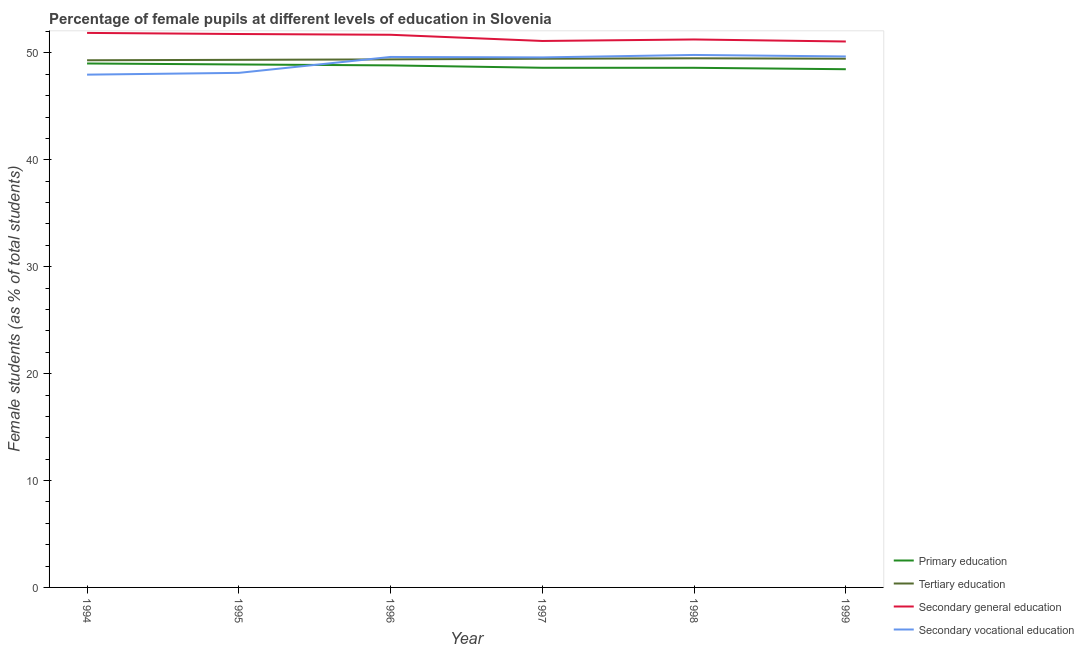How many different coloured lines are there?
Offer a very short reply. 4. What is the percentage of female students in tertiary education in 1996?
Offer a very short reply. 49.39. Across all years, what is the maximum percentage of female students in secondary education?
Provide a short and direct response. 51.87. Across all years, what is the minimum percentage of female students in secondary education?
Ensure brevity in your answer.  51.07. In which year was the percentage of female students in secondary vocational education minimum?
Your answer should be compact. 1994. What is the total percentage of female students in primary education in the graph?
Offer a very short reply. 292.46. What is the difference between the percentage of female students in tertiary education in 1995 and that in 1996?
Provide a short and direct response. -0.04. What is the difference between the percentage of female students in secondary vocational education in 1996 and the percentage of female students in secondary education in 1994?
Your response must be concise. -2.25. What is the average percentage of female students in primary education per year?
Make the answer very short. 48.74. In the year 1995, what is the difference between the percentage of female students in secondary education and percentage of female students in primary education?
Your response must be concise. 2.85. What is the ratio of the percentage of female students in secondary education in 1996 to that in 1998?
Make the answer very short. 1.01. Is the percentage of female students in tertiary education in 1994 less than that in 1996?
Your answer should be very brief. Yes. Is the difference between the percentage of female students in tertiary education in 1996 and 1997 greater than the difference between the percentage of female students in secondary education in 1996 and 1997?
Give a very brief answer. No. What is the difference between the highest and the second highest percentage of female students in secondary education?
Your answer should be compact. 0.1. What is the difference between the highest and the lowest percentage of female students in secondary vocational education?
Your answer should be compact. 1.84. Does the percentage of female students in primary education monotonically increase over the years?
Provide a short and direct response. No. Is the percentage of female students in secondary education strictly greater than the percentage of female students in secondary vocational education over the years?
Give a very brief answer. Yes. How many lines are there?
Keep it short and to the point. 4. How many years are there in the graph?
Offer a terse response. 6. Does the graph contain grids?
Offer a terse response. No. How are the legend labels stacked?
Your answer should be compact. Vertical. What is the title of the graph?
Offer a terse response. Percentage of female pupils at different levels of education in Slovenia. What is the label or title of the Y-axis?
Make the answer very short. Female students (as % of total students). What is the Female students (as % of total students) in Primary education in 1994?
Give a very brief answer. 49.01. What is the Female students (as % of total students) of Tertiary education in 1994?
Give a very brief answer. 49.31. What is the Female students (as % of total students) in Secondary general education in 1994?
Your response must be concise. 51.87. What is the Female students (as % of total students) of Secondary vocational education in 1994?
Keep it short and to the point. 47.97. What is the Female students (as % of total students) in Primary education in 1995?
Provide a short and direct response. 48.92. What is the Female students (as % of total students) of Tertiary education in 1995?
Provide a short and direct response. 49.35. What is the Female students (as % of total students) of Secondary general education in 1995?
Offer a terse response. 51.77. What is the Female students (as % of total students) of Secondary vocational education in 1995?
Make the answer very short. 48.13. What is the Female students (as % of total students) in Primary education in 1996?
Make the answer very short. 48.83. What is the Female students (as % of total students) in Tertiary education in 1996?
Provide a short and direct response. 49.39. What is the Female students (as % of total students) of Secondary general education in 1996?
Your answer should be compact. 51.7. What is the Female students (as % of total students) of Secondary vocational education in 1996?
Offer a very short reply. 49.62. What is the Female students (as % of total students) of Primary education in 1997?
Give a very brief answer. 48.61. What is the Female students (as % of total students) of Tertiary education in 1997?
Make the answer very short. 49.46. What is the Female students (as % of total students) of Secondary general education in 1997?
Keep it short and to the point. 51.12. What is the Female students (as % of total students) of Secondary vocational education in 1997?
Offer a terse response. 49.58. What is the Female students (as % of total students) in Primary education in 1998?
Provide a short and direct response. 48.61. What is the Female students (as % of total students) of Tertiary education in 1998?
Your response must be concise. 49.5. What is the Female students (as % of total students) of Secondary general education in 1998?
Ensure brevity in your answer.  51.26. What is the Female students (as % of total students) in Secondary vocational education in 1998?
Give a very brief answer. 49.81. What is the Female students (as % of total students) in Primary education in 1999?
Offer a very short reply. 48.47. What is the Female students (as % of total students) of Tertiary education in 1999?
Provide a succinct answer. 49.46. What is the Female students (as % of total students) of Secondary general education in 1999?
Your response must be concise. 51.07. What is the Female students (as % of total students) of Secondary vocational education in 1999?
Offer a terse response. 49.67. Across all years, what is the maximum Female students (as % of total students) in Primary education?
Give a very brief answer. 49.01. Across all years, what is the maximum Female students (as % of total students) in Tertiary education?
Your answer should be very brief. 49.5. Across all years, what is the maximum Female students (as % of total students) of Secondary general education?
Keep it short and to the point. 51.87. Across all years, what is the maximum Female students (as % of total students) of Secondary vocational education?
Your answer should be compact. 49.81. Across all years, what is the minimum Female students (as % of total students) of Primary education?
Make the answer very short. 48.47. Across all years, what is the minimum Female students (as % of total students) of Tertiary education?
Provide a short and direct response. 49.31. Across all years, what is the minimum Female students (as % of total students) of Secondary general education?
Make the answer very short. 51.07. Across all years, what is the minimum Female students (as % of total students) of Secondary vocational education?
Your answer should be very brief. 47.97. What is the total Female students (as % of total students) of Primary education in the graph?
Keep it short and to the point. 292.46. What is the total Female students (as % of total students) of Tertiary education in the graph?
Provide a short and direct response. 296.47. What is the total Female students (as % of total students) in Secondary general education in the graph?
Offer a very short reply. 308.78. What is the total Female students (as % of total students) of Secondary vocational education in the graph?
Your answer should be very brief. 294.78. What is the difference between the Female students (as % of total students) in Primary education in 1994 and that in 1995?
Your answer should be compact. 0.09. What is the difference between the Female students (as % of total students) in Tertiary education in 1994 and that in 1995?
Give a very brief answer. -0.04. What is the difference between the Female students (as % of total students) in Secondary general education in 1994 and that in 1995?
Your answer should be very brief. 0.1. What is the difference between the Female students (as % of total students) in Secondary vocational education in 1994 and that in 1995?
Offer a very short reply. -0.17. What is the difference between the Female students (as % of total students) in Primary education in 1994 and that in 1996?
Your answer should be compact. 0.18. What is the difference between the Female students (as % of total students) of Tertiary education in 1994 and that in 1996?
Keep it short and to the point. -0.08. What is the difference between the Female students (as % of total students) of Secondary general education in 1994 and that in 1996?
Your answer should be very brief. 0.17. What is the difference between the Female students (as % of total students) in Secondary vocational education in 1994 and that in 1996?
Give a very brief answer. -1.65. What is the difference between the Female students (as % of total students) in Primary education in 1994 and that in 1997?
Provide a succinct answer. 0.4. What is the difference between the Female students (as % of total students) in Tertiary education in 1994 and that in 1997?
Ensure brevity in your answer.  -0.14. What is the difference between the Female students (as % of total students) in Secondary general education in 1994 and that in 1997?
Your answer should be very brief. 0.75. What is the difference between the Female students (as % of total students) of Secondary vocational education in 1994 and that in 1997?
Provide a short and direct response. -1.61. What is the difference between the Female students (as % of total students) of Primary education in 1994 and that in 1998?
Offer a very short reply. 0.4. What is the difference between the Female students (as % of total students) of Tertiary education in 1994 and that in 1998?
Offer a very short reply. -0.18. What is the difference between the Female students (as % of total students) in Secondary general education in 1994 and that in 1998?
Your response must be concise. 0.61. What is the difference between the Female students (as % of total students) of Secondary vocational education in 1994 and that in 1998?
Make the answer very short. -1.84. What is the difference between the Female students (as % of total students) of Primary education in 1994 and that in 1999?
Provide a succinct answer. 0.54. What is the difference between the Female students (as % of total students) of Tertiary education in 1994 and that in 1999?
Your response must be concise. -0.15. What is the difference between the Female students (as % of total students) of Secondary general education in 1994 and that in 1999?
Your response must be concise. 0.8. What is the difference between the Female students (as % of total students) in Secondary vocational education in 1994 and that in 1999?
Keep it short and to the point. -1.7. What is the difference between the Female students (as % of total students) in Primary education in 1995 and that in 1996?
Your answer should be very brief. 0.09. What is the difference between the Female students (as % of total students) of Tertiary education in 1995 and that in 1996?
Your answer should be very brief. -0.04. What is the difference between the Female students (as % of total students) in Secondary general education in 1995 and that in 1996?
Provide a short and direct response. 0.07. What is the difference between the Female students (as % of total students) of Secondary vocational education in 1995 and that in 1996?
Give a very brief answer. -1.49. What is the difference between the Female students (as % of total students) of Primary education in 1995 and that in 1997?
Your answer should be very brief. 0.31. What is the difference between the Female students (as % of total students) in Tertiary education in 1995 and that in 1997?
Your response must be concise. -0.1. What is the difference between the Female students (as % of total students) of Secondary general education in 1995 and that in 1997?
Your answer should be compact. 0.65. What is the difference between the Female students (as % of total students) of Secondary vocational education in 1995 and that in 1997?
Provide a succinct answer. -1.45. What is the difference between the Female students (as % of total students) in Primary education in 1995 and that in 1998?
Your response must be concise. 0.31. What is the difference between the Female students (as % of total students) of Tertiary education in 1995 and that in 1998?
Provide a succinct answer. -0.14. What is the difference between the Female students (as % of total students) in Secondary general education in 1995 and that in 1998?
Your answer should be very brief. 0.51. What is the difference between the Female students (as % of total students) of Secondary vocational education in 1995 and that in 1998?
Your response must be concise. -1.68. What is the difference between the Female students (as % of total students) of Primary education in 1995 and that in 1999?
Your response must be concise. 0.44. What is the difference between the Female students (as % of total students) of Tertiary education in 1995 and that in 1999?
Your answer should be compact. -0.11. What is the difference between the Female students (as % of total students) in Secondary general education in 1995 and that in 1999?
Ensure brevity in your answer.  0.7. What is the difference between the Female students (as % of total students) in Secondary vocational education in 1995 and that in 1999?
Provide a short and direct response. -1.53. What is the difference between the Female students (as % of total students) in Primary education in 1996 and that in 1997?
Give a very brief answer. 0.22. What is the difference between the Female students (as % of total students) of Tertiary education in 1996 and that in 1997?
Ensure brevity in your answer.  -0.06. What is the difference between the Female students (as % of total students) of Secondary general education in 1996 and that in 1997?
Ensure brevity in your answer.  0.58. What is the difference between the Female students (as % of total students) of Secondary vocational education in 1996 and that in 1997?
Provide a short and direct response. 0.04. What is the difference between the Female students (as % of total students) in Primary education in 1996 and that in 1998?
Your answer should be very brief. 0.22. What is the difference between the Female students (as % of total students) in Tertiary education in 1996 and that in 1998?
Your answer should be compact. -0.1. What is the difference between the Female students (as % of total students) in Secondary general education in 1996 and that in 1998?
Ensure brevity in your answer.  0.44. What is the difference between the Female students (as % of total students) of Secondary vocational education in 1996 and that in 1998?
Keep it short and to the point. -0.19. What is the difference between the Female students (as % of total students) in Primary education in 1996 and that in 1999?
Keep it short and to the point. 0.36. What is the difference between the Female students (as % of total students) in Tertiary education in 1996 and that in 1999?
Offer a very short reply. -0.06. What is the difference between the Female students (as % of total students) in Secondary general education in 1996 and that in 1999?
Provide a short and direct response. 0.63. What is the difference between the Female students (as % of total students) in Secondary vocational education in 1996 and that in 1999?
Ensure brevity in your answer.  -0.05. What is the difference between the Female students (as % of total students) in Primary education in 1997 and that in 1998?
Provide a succinct answer. 0. What is the difference between the Female students (as % of total students) in Tertiary education in 1997 and that in 1998?
Offer a terse response. -0.04. What is the difference between the Female students (as % of total students) of Secondary general education in 1997 and that in 1998?
Your response must be concise. -0.14. What is the difference between the Female students (as % of total students) of Secondary vocational education in 1997 and that in 1998?
Ensure brevity in your answer.  -0.23. What is the difference between the Female students (as % of total students) in Primary education in 1997 and that in 1999?
Your answer should be compact. 0.14. What is the difference between the Female students (as % of total students) of Tertiary education in 1997 and that in 1999?
Ensure brevity in your answer.  -0. What is the difference between the Female students (as % of total students) in Secondary vocational education in 1997 and that in 1999?
Your answer should be very brief. -0.09. What is the difference between the Female students (as % of total students) in Primary education in 1998 and that in 1999?
Your answer should be compact. 0.13. What is the difference between the Female students (as % of total students) of Tertiary education in 1998 and that in 1999?
Offer a very short reply. 0.04. What is the difference between the Female students (as % of total students) in Secondary general education in 1998 and that in 1999?
Offer a very short reply. 0.19. What is the difference between the Female students (as % of total students) in Secondary vocational education in 1998 and that in 1999?
Provide a short and direct response. 0.14. What is the difference between the Female students (as % of total students) of Primary education in 1994 and the Female students (as % of total students) of Tertiary education in 1995?
Ensure brevity in your answer.  -0.34. What is the difference between the Female students (as % of total students) in Primary education in 1994 and the Female students (as % of total students) in Secondary general education in 1995?
Offer a terse response. -2.76. What is the difference between the Female students (as % of total students) of Primary education in 1994 and the Female students (as % of total students) of Secondary vocational education in 1995?
Offer a terse response. 0.88. What is the difference between the Female students (as % of total students) in Tertiary education in 1994 and the Female students (as % of total students) in Secondary general education in 1995?
Your answer should be compact. -2.46. What is the difference between the Female students (as % of total students) of Tertiary education in 1994 and the Female students (as % of total students) of Secondary vocational education in 1995?
Offer a very short reply. 1.18. What is the difference between the Female students (as % of total students) in Secondary general education in 1994 and the Female students (as % of total students) in Secondary vocational education in 1995?
Offer a very short reply. 3.74. What is the difference between the Female students (as % of total students) of Primary education in 1994 and the Female students (as % of total students) of Tertiary education in 1996?
Your answer should be compact. -0.38. What is the difference between the Female students (as % of total students) in Primary education in 1994 and the Female students (as % of total students) in Secondary general education in 1996?
Your answer should be very brief. -2.69. What is the difference between the Female students (as % of total students) in Primary education in 1994 and the Female students (as % of total students) in Secondary vocational education in 1996?
Give a very brief answer. -0.61. What is the difference between the Female students (as % of total students) in Tertiary education in 1994 and the Female students (as % of total students) in Secondary general education in 1996?
Ensure brevity in your answer.  -2.39. What is the difference between the Female students (as % of total students) of Tertiary education in 1994 and the Female students (as % of total students) of Secondary vocational education in 1996?
Make the answer very short. -0.31. What is the difference between the Female students (as % of total students) in Secondary general education in 1994 and the Female students (as % of total students) in Secondary vocational education in 1996?
Give a very brief answer. 2.25. What is the difference between the Female students (as % of total students) in Primary education in 1994 and the Female students (as % of total students) in Tertiary education in 1997?
Provide a succinct answer. -0.45. What is the difference between the Female students (as % of total students) of Primary education in 1994 and the Female students (as % of total students) of Secondary general education in 1997?
Keep it short and to the point. -2.11. What is the difference between the Female students (as % of total students) of Primary education in 1994 and the Female students (as % of total students) of Secondary vocational education in 1997?
Ensure brevity in your answer.  -0.57. What is the difference between the Female students (as % of total students) of Tertiary education in 1994 and the Female students (as % of total students) of Secondary general education in 1997?
Make the answer very short. -1.8. What is the difference between the Female students (as % of total students) of Tertiary education in 1994 and the Female students (as % of total students) of Secondary vocational education in 1997?
Make the answer very short. -0.27. What is the difference between the Female students (as % of total students) in Secondary general education in 1994 and the Female students (as % of total students) in Secondary vocational education in 1997?
Your response must be concise. 2.29. What is the difference between the Female students (as % of total students) in Primary education in 1994 and the Female students (as % of total students) in Tertiary education in 1998?
Your answer should be very brief. -0.48. What is the difference between the Female students (as % of total students) in Primary education in 1994 and the Female students (as % of total students) in Secondary general education in 1998?
Offer a very short reply. -2.25. What is the difference between the Female students (as % of total students) in Primary education in 1994 and the Female students (as % of total students) in Secondary vocational education in 1998?
Provide a succinct answer. -0.8. What is the difference between the Female students (as % of total students) of Tertiary education in 1994 and the Female students (as % of total students) of Secondary general education in 1998?
Ensure brevity in your answer.  -1.95. What is the difference between the Female students (as % of total students) of Tertiary education in 1994 and the Female students (as % of total students) of Secondary vocational education in 1998?
Your answer should be very brief. -0.5. What is the difference between the Female students (as % of total students) in Secondary general education in 1994 and the Female students (as % of total students) in Secondary vocational education in 1998?
Provide a short and direct response. 2.06. What is the difference between the Female students (as % of total students) of Primary education in 1994 and the Female students (as % of total students) of Tertiary education in 1999?
Your response must be concise. -0.45. What is the difference between the Female students (as % of total students) of Primary education in 1994 and the Female students (as % of total students) of Secondary general education in 1999?
Ensure brevity in your answer.  -2.06. What is the difference between the Female students (as % of total students) in Primary education in 1994 and the Female students (as % of total students) in Secondary vocational education in 1999?
Give a very brief answer. -0.66. What is the difference between the Female students (as % of total students) in Tertiary education in 1994 and the Female students (as % of total students) in Secondary general education in 1999?
Ensure brevity in your answer.  -1.75. What is the difference between the Female students (as % of total students) in Tertiary education in 1994 and the Female students (as % of total students) in Secondary vocational education in 1999?
Ensure brevity in your answer.  -0.36. What is the difference between the Female students (as % of total students) of Secondary general education in 1994 and the Female students (as % of total students) of Secondary vocational education in 1999?
Your answer should be very brief. 2.2. What is the difference between the Female students (as % of total students) in Primary education in 1995 and the Female students (as % of total students) in Tertiary education in 1996?
Your response must be concise. -0.48. What is the difference between the Female students (as % of total students) in Primary education in 1995 and the Female students (as % of total students) in Secondary general education in 1996?
Make the answer very short. -2.78. What is the difference between the Female students (as % of total students) in Primary education in 1995 and the Female students (as % of total students) in Secondary vocational education in 1996?
Ensure brevity in your answer.  -0.7. What is the difference between the Female students (as % of total students) of Tertiary education in 1995 and the Female students (as % of total students) of Secondary general education in 1996?
Ensure brevity in your answer.  -2.35. What is the difference between the Female students (as % of total students) of Tertiary education in 1995 and the Female students (as % of total students) of Secondary vocational education in 1996?
Keep it short and to the point. -0.27. What is the difference between the Female students (as % of total students) of Secondary general education in 1995 and the Female students (as % of total students) of Secondary vocational education in 1996?
Your answer should be very brief. 2.15. What is the difference between the Female students (as % of total students) of Primary education in 1995 and the Female students (as % of total students) of Tertiary education in 1997?
Make the answer very short. -0.54. What is the difference between the Female students (as % of total students) in Primary education in 1995 and the Female students (as % of total students) in Secondary general education in 1997?
Offer a very short reply. -2.2. What is the difference between the Female students (as % of total students) of Primary education in 1995 and the Female students (as % of total students) of Secondary vocational education in 1997?
Provide a succinct answer. -0.66. What is the difference between the Female students (as % of total students) of Tertiary education in 1995 and the Female students (as % of total students) of Secondary general education in 1997?
Your answer should be compact. -1.76. What is the difference between the Female students (as % of total students) of Tertiary education in 1995 and the Female students (as % of total students) of Secondary vocational education in 1997?
Provide a short and direct response. -0.23. What is the difference between the Female students (as % of total students) of Secondary general education in 1995 and the Female students (as % of total students) of Secondary vocational education in 1997?
Your answer should be very brief. 2.19. What is the difference between the Female students (as % of total students) of Primary education in 1995 and the Female students (as % of total students) of Tertiary education in 1998?
Your response must be concise. -0.58. What is the difference between the Female students (as % of total students) of Primary education in 1995 and the Female students (as % of total students) of Secondary general education in 1998?
Offer a terse response. -2.34. What is the difference between the Female students (as % of total students) of Primary education in 1995 and the Female students (as % of total students) of Secondary vocational education in 1998?
Give a very brief answer. -0.89. What is the difference between the Female students (as % of total students) in Tertiary education in 1995 and the Female students (as % of total students) in Secondary general education in 1998?
Ensure brevity in your answer.  -1.9. What is the difference between the Female students (as % of total students) of Tertiary education in 1995 and the Female students (as % of total students) of Secondary vocational education in 1998?
Give a very brief answer. -0.46. What is the difference between the Female students (as % of total students) of Secondary general education in 1995 and the Female students (as % of total students) of Secondary vocational education in 1998?
Provide a succinct answer. 1.96. What is the difference between the Female students (as % of total students) in Primary education in 1995 and the Female students (as % of total students) in Tertiary education in 1999?
Give a very brief answer. -0.54. What is the difference between the Female students (as % of total students) in Primary education in 1995 and the Female students (as % of total students) in Secondary general education in 1999?
Your response must be concise. -2.15. What is the difference between the Female students (as % of total students) of Primary education in 1995 and the Female students (as % of total students) of Secondary vocational education in 1999?
Your answer should be compact. -0.75. What is the difference between the Female students (as % of total students) of Tertiary education in 1995 and the Female students (as % of total students) of Secondary general education in 1999?
Keep it short and to the point. -1.71. What is the difference between the Female students (as % of total students) in Tertiary education in 1995 and the Female students (as % of total students) in Secondary vocational education in 1999?
Give a very brief answer. -0.32. What is the difference between the Female students (as % of total students) of Secondary general education in 1995 and the Female students (as % of total students) of Secondary vocational education in 1999?
Give a very brief answer. 2.1. What is the difference between the Female students (as % of total students) of Primary education in 1996 and the Female students (as % of total students) of Tertiary education in 1997?
Provide a short and direct response. -0.62. What is the difference between the Female students (as % of total students) in Primary education in 1996 and the Female students (as % of total students) in Secondary general education in 1997?
Provide a short and direct response. -2.28. What is the difference between the Female students (as % of total students) of Primary education in 1996 and the Female students (as % of total students) of Secondary vocational education in 1997?
Ensure brevity in your answer.  -0.75. What is the difference between the Female students (as % of total students) in Tertiary education in 1996 and the Female students (as % of total students) in Secondary general education in 1997?
Give a very brief answer. -1.72. What is the difference between the Female students (as % of total students) in Tertiary education in 1996 and the Female students (as % of total students) in Secondary vocational education in 1997?
Offer a very short reply. -0.19. What is the difference between the Female students (as % of total students) in Secondary general education in 1996 and the Female students (as % of total students) in Secondary vocational education in 1997?
Provide a short and direct response. 2.12. What is the difference between the Female students (as % of total students) of Primary education in 1996 and the Female students (as % of total students) of Tertiary education in 1998?
Keep it short and to the point. -0.66. What is the difference between the Female students (as % of total students) in Primary education in 1996 and the Female students (as % of total students) in Secondary general education in 1998?
Ensure brevity in your answer.  -2.43. What is the difference between the Female students (as % of total students) in Primary education in 1996 and the Female students (as % of total students) in Secondary vocational education in 1998?
Offer a terse response. -0.98. What is the difference between the Female students (as % of total students) in Tertiary education in 1996 and the Female students (as % of total students) in Secondary general education in 1998?
Your answer should be compact. -1.86. What is the difference between the Female students (as % of total students) in Tertiary education in 1996 and the Female students (as % of total students) in Secondary vocational education in 1998?
Your answer should be very brief. -0.41. What is the difference between the Female students (as % of total students) in Secondary general education in 1996 and the Female students (as % of total students) in Secondary vocational education in 1998?
Offer a terse response. 1.89. What is the difference between the Female students (as % of total students) of Primary education in 1996 and the Female students (as % of total students) of Tertiary education in 1999?
Keep it short and to the point. -0.63. What is the difference between the Female students (as % of total students) in Primary education in 1996 and the Female students (as % of total students) in Secondary general education in 1999?
Make the answer very short. -2.23. What is the difference between the Female students (as % of total students) in Primary education in 1996 and the Female students (as % of total students) in Secondary vocational education in 1999?
Make the answer very short. -0.84. What is the difference between the Female students (as % of total students) of Tertiary education in 1996 and the Female students (as % of total students) of Secondary general education in 1999?
Give a very brief answer. -1.67. What is the difference between the Female students (as % of total students) of Tertiary education in 1996 and the Female students (as % of total students) of Secondary vocational education in 1999?
Your answer should be compact. -0.27. What is the difference between the Female students (as % of total students) of Secondary general education in 1996 and the Female students (as % of total students) of Secondary vocational education in 1999?
Keep it short and to the point. 2.03. What is the difference between the Female students (as % of total students) of Primary education in 1997 and the Female students (as % of total students) of Tertiary education in 1998?
Your response must be concise. -0.88. What is the difference between the Female students (as % of total students) in Primary education in 1997 and the Female students (as % of total students) in Secondary general education in 1998?
Your response must be concise. -2.65. What is the difference between the Female students (as % of total students) of Primary education in 1997 and the Female students (as % of total students) of Secondary vocational education in 1998?
Make the answer very short. -1.2. What is the difference between the Female students (as % of total students) in Tertiary education in 1997 and the Female students (as % of total students) in Secondary general education in 1998?
Give a very brief answer. -1.8. What is the difference between the Female students (as % of total students) of Tertiary education in 1997 and the Female students (as % of total students) of Secondary vocational education in 1998?
Your answer should be very brief. -0.35. What is the difference between the Female students (as % of total students) in Secondary general education in 1997 and the Female students (as % of total students) in Secondary vocational education in 1998?
Offer a very short reply. 1.31. What is the difference between the Female students (as % of total students) of Primary education in 1997 and the Female students (as % of total students) of Tertiary education in 1999?
Make the answer very short. -0.85. What is the difference between the Female students (as % of total students) of Primary education in 1997 and the Female students (as % of total students) of Secondary general education in 1999?
Provide a succinct answer. -2.46. What is the difference between the Female students (as % of total students) of Primary education in 1997 and the Female students (as % of total students) of Secondary vocational education in 1999?
Ensure brevity in your answer.  -1.06. What is the difference between the Female students (as % of total students) in Tertiary education in 1997 and the Female students (as % of total students) in Secondary general education in 1999?
Ensure brevity in your answer.  -1.61. What is the difference between the Female students (as % of total students) of Tertiary education in 1997 and the Female students (as % of total students) of Secondary vocational education in 1999?
Your answer should be very brief. -0.21. What is the difference between the Female students (as % of total students) in Secondary general education in 1997 and the Female students (as % of total students) in Secondary vocational education in 1999?
Ensure brevity in your answer.  1.45. What is the difference between the Female students (as % of total students) of Primary education in 1998 and the Female students (as % of total students) of Tertiary education in 1999?
Ensure brevity in your answer.  -0.85. What is the difference between the Female students (as % of total students) in Primary education in 1998 and the Female students (as % of total students) in Secondary general education in 1999?
Make the answer very short. -2.46. What is the difference between the Female students (as % of total students) of Primary education in 1998 and the Female students (as % of total students) of Secondary vocational education in 1999?
Provide a short and direct response. -1.06. What is the difference between the Female students (as % of total students) of Tertiary education in 1998 and the Female students (as % of total students) of Secondary general education in 1999?
Make the answer very short. -1.57. What is the difference between the Female students (as % of total students) in Tertiary education in 1998 and the Female students (as % of total students) in Secondary vocational education in 1999?
Your response must be concise. -0.17. What is the difference between the Female students (as % of total students) in Secondary general education in 1998 and the Female students (as % of total students) in Secondary vocational education in 1999?
Provide a succinct answer. 1.59. What is the average Female students (as % of total students) of Primary education per year?
Offer a very short reply. 48.74. What is the average Female students (as % of total students) in Tertiary education per year?
Your response must be concise. 49.41. What is the average Female students (as % of total students) in Secondary general education per year?
Make the answer very short. 51.46. What is the average Female students (as % of total students) in Secondary vocational education per year?
Provide a short and direct response. 49.13. In the year 1994, what is the difference between the Female students (as % of total students) of Primary education and Female students (as % of total students) of Tertiary education?
Give a very brief answer. -0.3. In the year 1994, what is the difference between the Female students (as % of total students) in Primary education and Female students (as % of total students) in Secondary general education?
Make the answer very short. -2.86. In the year 1994, what is the difference between the Female students (as % of total students) in Primary education and Female students (as % of total students) in Secondary vocational education?
Ensure brevity in your answer.  1.04. In the year 1994, what is the difference between the Female students (as % of total students) of Tertiary education and Female students (as % of total students) of Secondary general education?
Offer a very short reply. -2.56. In the year 1994, what is the difference between the Female students (as % of total students) of Tertiary education and Female students (as % of total students) of Secondary vocational education?
Your answer should be very brief. 1.34. In the year 1994, what is the difference between the Female students (as % of total students) in Secondary general education and Female students (as % of total students) in Secondary vocational education?
Your answer should be very brief. 3.9. In the year 1995, what is the difference between the Female students (as % of total students) in Primary education and Female students (as % of total students) in Tertiary education?
Your answer should be very brief. -0.43. In the year 1995, what is the difference between the Female students (as % of total students) of Primary education and Female students (as % of total students) of Secondary general education?
Provide a short and direct response. -2.85. In the year 1995, what is the difference between the Female students (as % of total students) in Primary education and Female students (as % of total students) in Secondary vocational education?
Your answer should be very brief. 0.79. In the year 1995, what is the difference between the Female students (as % of total students) in Tertiary education and Female students (as % of total students) in Secondary general education?
Provide a short and direct response. -2.42. In the year 1995, what is the difference between the Female students (as % of total students) in Tertiary education and Female students (as % of total students) in Secondary vocational education?
Your answer should be compact. 1.22. In the year 1995, what is the difference between the Female students (as % of total students) of Secondary general education and Female students (as % of total students) of Secondary vocational education?
Offer a very short reply. 3.63. In the year 1996, what is the difference between the Female students (as % of total students) of Primary education and Female students (as % of total students) of Tertiary education?
Offer a very short reply. -0.56. In the year 1996, what is the difference between the Female students (as % of total students) in Primary education and Female students (as % of total students) in Secondary general education?
Your answer should be very brief. -2.87. In the year 1996, what is the difference between the Female students (as % of total students) of Primary education and Female students (as % of total students) of Secondary vocational education?
Your response must be concise. -0.79. In the year 1996, what is the difference between the Female students (as % of total students) of Tertiary education and Female students (as % of total students) of Secondary general education?
Provide a succinct answer. -2.3. In the year 1996, what is the difference between the Female students (as % of total students) in Tertiary education and Female students (as % of total students) in Secondary vocational education?
Your response must be concise. -0.23. In the year 1996, what is the difference between the Female students (as % of total students) in Secondary general education and Female students (as % of total students) in Secondary vocational education?
Offer a terse response. 2.08. In the year 1997, what is the difference between the Female students (as % of total students) in Primary education and Female students (as % of total students) in Tertiary education?
Your answer should be compact. -0.85. In the year 1997, what is the difference between the Female students (as % of total students) in Primary education and Female students (as % of total students) in Secondary general education?
Make the answer very short. -2.51. In the year 1997, what is the difference between the Female students (as % of total students) in Primary education and Female students (as % of total students) in Secondary vocational education?
Your answer should be compact. -0.97. In the year 1997, what is the difference between the Female students (as % of total students) of Tertiary education and Female students (as % of total students) of Secondary general education?
Offer a very short reply. -1.66. In the year 1997, what is the difference between the Female students (as % of total students) of Tertiary education and Female students (as % of total students) of Secondary vocational education?
Ensure brevity in your answer.  -0.12. In the year 1997, what is the difference between the Female students (as % of total students) of Secondary general education and Female students (as % of total students) of Secondary vocational education?
Ensure brevity in your answer.  1.54. In the year 1998, what is the difference between the Female students (as % of total students) in Primary education and Female students (as % of total students) in Tertiary education?
Provide a short and direct response. -0.89. In the year 1998, what is the difference between the Female students (as % of total students) in Primary education and Female students (as % of total students) in Secondary general education?
Your answer should be compact. -2.65. In the year 1998, what is the difference between the Female students (as % of total students) of Primary education and Female students (as % of total students) of Secondary vocational education?
Your response must be concise. -1.2. In the year 1998, what is the difference between the Female students (as % of total students) of Tertiary education and Female students (as % of total students) of Secondary general education?
Provide a short and direct response. -1.76. In the year 1998, what is the difference between the Female students (as % of total students) in Tertiary education and Female students (as % of total students) in Secondary vocational education?
Your answer should be very brief. -0.31. In the year 1998, what is the difference between the Female students (as % of total students) in Secondary general education and Female students (as % of total students) in Secondary vocational education?
Your answer should be very brief. 1.45. In the year 1999, what is the difference between the Female students (as % of total students) of Primary education and Female students (as % of total students) of Tertiary education?
Keep it short and to the point. -0.98. In the year 1999, what is the difference between the Female students (as % of total students) in Primary education and Female students (as % of total students) in Secondary general education?
Provide a short and direct response. -2.59. In the year 1999, what is the difference between the Female students (as % of total students) of Primary education and Female students (as % of total students) of Secondary vocational education?
Give a very brief answer. -1.19. In the year 1999, what is the difference between the Female students (as % of total students) in Tertiary education and Female students (as % of total students) in Secondary general education?
Offer a very short reply. -1.61. In the year 1999, what is the difference between the Female students (as % of total students) of Tertiary education and Female students (as % of total students) of Secondary vocational education?
Provide a short and direct response. -0.21. In the year 1999, what is the difference between the Female students (as % of total students) in Secondary general education and Female students (as % of total students) in Secondary vocational education?
Keep it short and to the point. 1.4. What is the ratio of the Female students (as % of total students) in Primary education in 1994 to that in 1995?
Offer a terse response. 1. What is the ratio of the Female students (as % of total students) of Secondary general education in 1994 to that in 1995?
Give a very brief answer. 1. What is the ratio of the Female students (as % of total students) in Primary education in 1994 to that in 1996?
Your answer should be compact. 1. What is the ratio of the Female students (as % of total students) in Tertiary education in 1994 to that in 1996?
Your answer should be very brief. 1. What is the ratio of the Female students (as % of total students) in Secondary vocational education in 1994 to that in 1996?
Ensure brevity in your answer.  0.97. What is the ratio of the Female students (as % of total students) in Primary education in 1994 to that in 1997?
Keep it short and to the point. 1.01. What is the ratio of the Female students (as % of total students) of Secondary general education in 1994 to that in 1997?
Offer a very short reply. 1.01. What is the ratio of the Female students (as % of total students) of Secondary vocational education in 1994 to that in 1997?
Ensure brevity in your answer.  0.97. What is the ratio of the Female students (as % of total students) in Primary education in 1994 to that in 1998?
Your answer should be very brief. 1.01. What is the ratio of the Female students (as % of total students) of Secondary vocational education in 1994 to that in 1998?
Make the answer very short. 0.96. What is the ratio of the Female students (as % of total students) of Primary education in 1994 to that in 1999?
Give a very brief answer. 1.01. What is the ratio of the Female students (as % of total students) of Tertiary education in 1994 to that in 1999?
Offer a very short reply. 1. What is the ratio of the Female students (as % of total students) of Secondary general education in 1994 to that in 1999?
Give a very brief answer. 1.02. What is the ratio of the Female students (as % of total students) of Secondary vocational education in 1994 to that in 1999?
Provide a succinct answer. 0.97. What is the ratio of the Female students (as % of total students) in Tertiary education in 1995 to that in 1996?
Your answer should be compact. 1. What is the ratio of the Female students (as % of total students) of Tertiary education in 1995 to that in 1997?
Provide a short and direct response. 1. What is the ratio of the Female students (as % of total students) in Secondary general education in 1995 to that in 1997?
Provide a short and direct response. 1.01. What is the ratio of the Female students (as % of total students) in Secondary vocational education in 1995 to that in 1997?
Your answer should be compact. 0.97. What is the ratio of the Female students (as % of total students) in Primary education in 1995 to that in 1998?
Keep it short and to the point. 1.01. What is the ratio of the Female students (as % of total students) in Tertiary education in 1995 to that in 1998?
Offer a terse response. 1. What is the ratio of the Female students (as % of total students) in Secondary vocational education in 1995 to that in 1998?
Your answer should be very brief. 0.97. What is the ratio of the Female students (as % of total students) of Primary education in 1995 to that in 1999?
Offer a terse response. 1.01. What is the ratio of the Female students (as % of total students) of Tertiary education in 1995 to that in 1999?
Offer a terse response. 1. What is the ratio of the Female students (as % of total students) of Secondary general education in 1995 to that in 1999?
Give a very brief answer. 1.01. What is the ratio of the Female students (as % of total students) in Secondary vocational education in 1995 to that in 1999?
Provide a short and direct response. 0.97. What is the ratio of the Female students (as % of total students) of Primary education in 1996 to that in 1997?
Ensure brevity in your answer.  1. What is the ratio of the Female students (as % of total students) of Secondary general education in 1996 to that in 1997?
Your response must be concise. 1.01. What is the ratio of the Female students (as % of total students) in Primary education in 1996 to that in 1998?
Provide a succinct answer. 1. What is the ratio of the Female students (as % of total students) in Secondary general education in 1996 to that in 1998?
Offer a very short reply. 1.01. What is the ratio of the Female students (as % of total students) in Primary education in 1996 to that in 1999?
Give a very brief answer. 1.01. What is the ratio of the Female students (as % of total students) in Tertiary education in 1996 to that in 1999?
Provide a succinct answer. 1. What is the ratio of the Female students (as % of total students) in Secondary general education in 1996 to that in 1999?
Your answer should be very brief. 1.01. What is the ratio of the Female students (as % of total students) of Secondary general education in 1997 to that in 1998?
Give a very brief answer. 1. What is the ratio of the Female students (as % of total students) in Secondary vocational education in 1997 to that in 1998?
Provide a succinct answer. 1. What is the ratio of the Female students (as % of total students) in Primary education in 1997 to that in 1999?
Your answer should be compact. 1. What is the ratio of the Female students (as % of total students) in Tertiary education in 1997 to that in 1999?
Give a very brief answer. 1. What is the ratio of the Female students (as % of total students) in Secondary general education in 1997 to that in 1999?
Offer a terse response. 1. What is the ratio of the Female students (as % of total students) of Primary education in 1998 to that in 1999?
Your response must be concise. 1. What is the ratio of the Female students (as % of total students) in Tertiary education in 1998 to that in 1999?
Offer a terse response. 1. What is the difference between the highest and the second highest Female students (as % of total students) of Primary education?
Keep it short and to the point. 0.09. What is the difference between the highest and the second highest Female students (as % of total students) of Tertiary education?
Make the answer very short. 0.04. What is the difference between the highest and the second highest Female students (as % of total students) of Secondary general education?
Your answer should be compact. 0.1. What is the difference between the highest and the second highest Female students (as % of total students) in Secondary vocational education?
Offer a terse response. 0.14. What is the difference between the highest and the lowest Female students (as % of total students) in Primary education?
Offer a very short reply. 0.54. What is the difference between the highest and the lowest Female students (as % of total students) of Tertiary education?
Provide a succinct answer. 0.18. What is the difference between the highest and the lowest Female students (as % of total students) of Secondary general education?
Provide a succinct answer. 0.8. What is the difference between the highest and the lowest Female students (as % of total students) of Secondary vocational education?
Give a very brief answer. 1.84. 